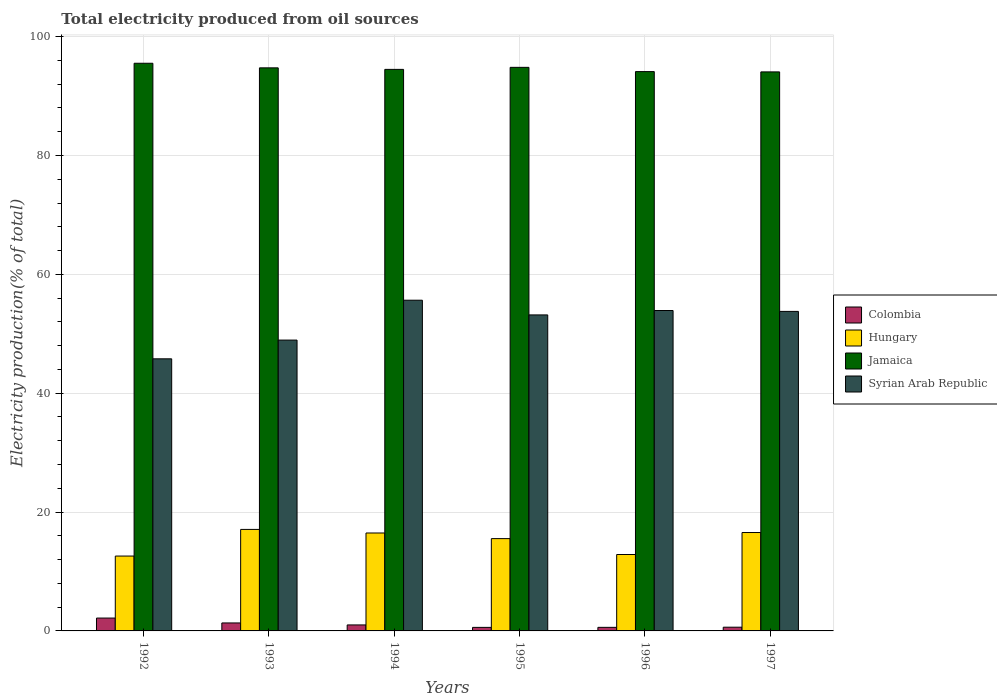How many different coloured bars are there?
Keep it short and to the point. 4. Are the number of bars on each tick of the X-axis equal?
Provide a short and direct response. Yes. How many bars are there on the 2nd tick from the left?
Provide a short and direct response. 4. What is the label of the 2nd group of bars from the left?
Make the answer very short. 1993. In how many cases, is the number of bars for a given year not equal to the number of legend labels?
Provide a succinct answer. 0. What is the total electricity produced in Hungary in 1997?
Your answer should be compact. 16.56. Across all years, what is the maximum total electricity produced in Hungary?
Keep it short and to the point. 17.08. Across all years, what is the minimum total electricity produced in Jamaica?
Your answer should be compact. 94.07. In which year was the total electricity produced in Syrian Arab Republic maximum?
Provide a short and direct response. 1994. What is the total total electricity produced in Syrian Arab Republic in the graph?
Offer a very short reply. 311.24. What is the difference between the total electricity produced in Hungary in 1994 and that in 1995?
Make the answer very short. 0.95. What is the difference between the total electricity produced in Syrian Arab Republic in 1996 and the total electricity produced in Jamaica in 1995?
Offer a terse response. -40.92. What is the average total electricity produced in Jamaica per year?
Ensure brevity in your answer.  94.63. In the year 1995, what is the difference between the total electricity produced in Jamaica and total electricity produced in Syrian Arab Republic?
Your answer should be very brief. 41.66. In how many years, is the total electricity produced in Hungary greater than 84 %?
Provide a short and direct response. 0. What is the ratio of the total electricity produced in Jamaica in 1992 to that in 1993?
Make the answer very short. 1.01. Is the total electricity produced in Syrian Arab Republic in 1996 less than that in 1997?
Give a very brief answer. No. Is the difference between the total electricity produced in Jamaica in 1994 and 1995 greater than the difference between the total electricity produced in Syrian Arab Republic in 1994 and 1995?
Provide a succinct answer. No. What is the difference between the highest and the second highest total electricity produced in Colombia?
Your answer should be compact. 0.82. What is the difference between the highest and the lowest total electricity produced in Syrian Arab Republic?
Your response must be concise. 9.86. Is the sum of the total electricity produced in Jamaica in 1995 and 1997 greater than the maximum total electricity produced in Colombia across all years?
Offer a terse response. Yes. What does the 2nd bar from the left in 1997 represents?
Provide a short and direct response. Hungary. What does the 2nd bar from the right in 1995 represents?
Offer a terse response. Jamaica. How many bars are there?
Make the answer very short. 24. Are all the bars in the graph horizontal?
Keep it short and to the point. No. How many years are there in the graph?
Keep it short and to the point. 6. Are the values on the major ticks of Y-axis written in scientific E-notation?
Ensure brevity in your answer.  No. Does the graph contain any zero values?
Give a very brief answer. No. How many legend labels are there?
Your answer should be very brief. 4. What is the title of the graph?
Ensure brevity in your answer.  Total electricity produced from oil sources. Does "East Asia (developing only)" appear as one of the legend labels in the graph?
Your response must be concise. No. What is the label or title of the X-axis?
Your answer should be compact. Years. What is the label or title of the Y-axis?
Give a very brief answer. Electricity production(% of total). What is the Electricity production(% of total) of Colombia in 1992?
Your response must be concise. 2.16. What is the Electricity production(% of total) of Hungary in 1992?
Ensure brevity in your answer.  12.6. What is the Electricity production(% of total) of Jamaica in 1992?
Provide a short and direct response. 95.52. What is the Electricity production(% of total) in Syrian Arab Republic in 1992?
Offer a terse response. 45.79. What is the Electricity production(% of total) of Colombia in 1993?
Make the answer very short. 1.34. What is the Electricity production(% of total) in Hungary in 1993?
Keep it short and to the point. 17.08. What is the Electricity production(% of total) in Jamaica in 1993?
Keep it short and to the point. 94.75. What is the Electricity production(% of total) of Syrian Arab Republic in 1993?
Offer a very short reply. 48.94. What is the Electricity production(% of total) of Colombia in 1994?
Offer a very short reply. 1.01. What is the Electricity production(% of total) of Hungary in 1994?
Make the answer very short. 16.48. What is the Electricity production(% of total) in Jamaica in 1994?
Keep it short and to the point. 94.49. What is the Electricity production(% of total) in Syrian Arab Republic in 1994?
Your answer should be very brief. 55.65. What is the Electricity production(% of total) of Colombia in 1995?
Your answer should be compact. 0.59. What is the Electricity production(% of total) in Hungary in 1995?
Keep it short and to the point. 15.53. What is the Electricity production(% of total) of Jamaica in 1995?
Keep it short and to the point. 94.84. What is the Electricity production(% of total) in Syrian Arab Republic in 1995?
Make the answer very short. 53.18. What is the Electricity production(% of total) in Colombia in 1996?
Ensure brevity in your answer.  0.6. What is the Electricity production(% of total) of Hungary in 1996?
Your response must be concise. 12.86. What is the Electricity production(% of total) in Jamaica in 1996?
Ensure brevity in your answer.  94.12. What is the Electricity production(% of total) in Syrian Arab Republic in 1996?
Your response must be concise. 53.92. What is the Electricity production(% of total) of Colombia in 1997?
Give a very brief answer. 0.63. What is the Electricity production(% of total) of Hungary in 1997?
Your answer should be compact. 16.56. What is the Electricity production(% of total) of Jamaica in 1997?
Your answer should be compact. 94.07. What is the Electricity production(% of total) of Syrian Arab Republic in 1997?
Your answer should be very brief. 53.77. Across all years, what is the maximum Electricity production(% of total) of Colombia?
Your answer should be compact. 2.16. Across all years, what is the maximum Electricity production(% of total) in Hungary?
Your answer should be very brief. 17.08. Across all years, what is the maximum Electricity production(% of total) of Jamaica?
Your answer should be very brief. 95.52. Across all years, what is the maximum Electricity production(% of total) in Syrian Arab Republic?
Give a very brief answer. 55.65. Across all years, what is the minimum Electricity production(% of total) of Colombia?
Your answer should be very brief. 0.59. Across all years, what is the minimum Electricity production(% of total) in Hungary?
Offer a terse response. 12.6. Across all years, what is the minimum Electricity production(% of total) of Jamaica?
Your answer should be very brief. 94.07. Across all years, what is the minimum Electricity production(% of total) in Syrian Arab Republic?
Give a very brief answer. 45.79. What is the total Electricity production(% of total) in Colombia in the graph?
Provide a short and direct response. 6.34. What is the total Electricity production(% of total) in Hungary in the graph?
Your answer should be compact. 91.11. What is the total Electricity production(% of total) in Jamaica in the graph?
Ensure brevity in your answer.  567.79. What is the total Electricity production(% of total) of Syrian Arab Republic in the graph?
Make the answer very short. 311.24. What is the difference between the Electricity production(% of total) in Colombia in 1992 and that in 1993?
Ensure brevity in your answer.  0.82. What is the difference between the Electricity production(% of total) in Hungary in 1992 and that in 1993?
Your answer should be compact. -4.48. What is the difference between the Electricity production(% of total) in Jamaica in 1992 and that in 1993?
Your answer should be compact. 0.77. What is the difference between the Electricity production(% of total) of Syrian Arab Republic in 1992 and that in 1993?
Provide a short and direct response. -3.15. What is the difference between the Electricity production(% of total) in Colombia in 1992 and that in 1994?
Provide a succinct answer. 1.15. What is the difference between the Electricity production(% of total) of Hungary in 1992 and that in 1994?
Keep it short and to the point. -3.88. What is the difference between the Electricity production(% of total) in Jamaica in 1992 and that in 1994?
Offer a very short reply. 1.03. What is the difference between the Electricity production(% of total) of Syrian Arab Republic in 1992 and that in 1994?
Ensure brevity in your answer.  -9.86. What is the difference between the Electricity production(% of total) in Colombia in 1992 and that in 1995?
Give a very brief answer. 1.57. What is the difference between the Electricity production(% of total) in Hungary in 1992 and that in 1995?
Your answer should be compact. -2.93. What is the difference between the Electricity production(% of total) in Jamaica in 1992 and that in 1995?
Make the answer very short. 0.69. What is the difference between the Electricity production(% of total) in Syrian Arab Republic in 1992 and that in 1995?
Keep it short and to the point. -7.39. What is the difference between the Electricity production(% of total) of Colombia in 1992 and that in 1996?
Ensure brevity in your answer.  1.56. What is the difference between the Electricity production(% of total) of Hungary in 1992 and that in 1996?
Provide a short and direct response. -0.26. What is the difference between the Electricity production(% of total) of Jamaica in 1992 and that in 1996?
Your response must be concise. 1.4. What is the difference between the Electricity production(% of total) in Syrian Arab Republic in 1992 and that in 1996?
Make the answer very short. -8.13. What is the difference between the Electricity production(% of total) of Colombia in 1992 and that in 1997?
Provide a succinct answer. 1.54. What is the difference between the Electricity production(% of total) in Hungary in 1992 and that in 1997?
Your answer should be compact. -3.96. What is the difference between the Electricity production(% of total) of Jamaica in 1992 and that in 1997?
Offer a very short reply. 1.46. What is the difference between the Electricity production(% of total) in Syrian Arab Republic in 1992 and that in 1997?
Give a very brief answer. -7.98. What is the difference between the Electricity production(% of total) in Colombia in 1993 and that in 1994?
Provide a short and direct response. 0.33. What is the difference between the Electricity production(% of total) of Hungary in 1993 and that in 1994?
Offer a very short reply. 0.6. What is the difference between the Electricity production(% of total) of Jamaica in 1993 and that in 1994?
Your response must be concise. 0.26. What is the difference between the Electricity production(% of total) of Syrian Arab Republic in 1993 and that in 1994?
Offer a very short reply. -6.71. What is the difference between the Electricity production(% of total) in Colombia in 1993 and that in 1995?
Ensure brevity in your answer.  0.75. What is the difference between the Electricity production(% of total) of Hungary in 1993 and that in 1995?
Your answer should be very brief. 1.55. What is the difference between the Electricity production(% of total) in Jamaica in 1993 and that in 1995?
Provide a succinct answer. -0.09. What is the difference between the Electricity production(% of total) in Syrian Arab Republic in 1993 and that in 1995?
Your answer should be compact. -4.24. What is the difference between the Electricity production(% of total) in Colombia in 1993 and that in 1996?
Provide a succinct answer. 0.74. What is the difference between the Electricity production(% of total) in Hungary in 1993 and that in 1996?
Make the answer very short. 4.22. What is the difference between the Electricity production(% of total) of Jamaica in 1993 and that in 1996?
Make the answer very short. 0.63. What is the difference between the Electricity production(% of total) of Syrian Arab Republic in 1993 and that in 1996?
Make the answer very short. -4.98. What is the difference between the Electricity production(% of total) of Colombia in 1993 and that in 1997?
Offer a terse response. 0.72. What is the difference between the Electricity production(% of total) of Hungary in 1993 and that in 1997?
Provide a succinct answer. 0.52. What is the difference between the Electricity production(% of total) of Jamaica in 1993 and that in 1997?
Provide a short and direct response. 0.68. What is the difference between the Electricity production(% of total) in Syrian Arab Republic in 1993 and that in 1997?
Offer a terse response. -4.83. What is the difference between the Electricity production(% of total) in Colombia in 1994 and that in 1995?
Make the answer very short. 0.41. What is the difference between the Electricity production(% of total) of Hungary in 1994 and that in 1995?
Give a very brief answer. 0.95. What is the difference between the Electricity production(% of total) of Jamaica in 1994 and that in 1995?
Your response must be concise. -0.34. What is the difference between the Electricity production(% of total) of Syrian Arab Republic in 1994 and that in 1995?
Offer a terse response. 2.47. What is the difference between the Electricity production(% of total) of Colombia in 1994 and that in 1996?
Your answer should be very brief. 0.41. What is the difference between the Electricity production(% of total) of Hungary in 1994 and that in 1996?
Keep it short and to the point. 3.62. What is the difference between the Electricity production(% of total) in Jamaica in 1994 and that in 1996?
Your answer should be compact. 0.37. What is the difference between the Electricity production(% of total) in Syrian Arab Republic in 1994 and that in 1996?
Your answer should be very brief. 1.73. What is the difference between the Electricity production(% of total) of Colombia in 1994 and that in 1997?
Give a very brief answer. 0.38. What is the difference between the Electricity production(% of total) of Hungary in 1994 and that in 1997?
Offer a very short reply. -0.08. What is the difference between the Electricity production(% of total) of Jamaica in 1994 and that in 1997?
Your response must be concise. 0.42. What is the difference between the Electricity production(% of total) in Syrian Arab Republic in 1994 and that in 1997?
Offer a very short reply. 1.88. What is the difference between the Electricity production(% of total) of Colombia in 1995 and that in 1996?
Provide a succinct answer. -0.01. What is the difference between the Electricity production(% of total) of Hungary in 1995 and that in 1996?
Give a very brief answer. 2.67. What is the difference between the Electricity production(% of total) in Jamaica in 1995 and that in 1996?
Offer a terse response. 0.72. What is the difference between the Electricity production(% of total) in Syrian Arab Republic in 1995 and that in 1996?
Offer a terse response. -0.74. What is the difference between the Electricity production(% of total) in Colombia in 1995 and that in 1997?
Offer a terse response. -0.03. What is the difference between the Electricity production(% of total) of Hungary in 1995 and that in 1997?
Your answer should be very brief. -1.02. What is the difference between the Electricity production(% of total) of Jamaica in 1995 and that in 1997?
Your answer should be very brief. 0.77. What is the difference between the Electricity production(% of total) in Syrian Arab Republic in 1995 and that in 1997?
Your answer should be very brief. -0.59. What is the difference between the Electricity production(% of total) of Colombia in 1996 and that in 1997?
Offer a very short reply. -0.03. What is the difference between the Electricity production(% of total) in Hungary in 1996 and that in 1997?
Give a very brief answer. -3.7. What is the difference between the Electricity production(% of total) in Jamaica in 1996 and that in 1997?
Make the answer very short. 0.05. What is the difference between the Electricity production(% of total) of Syrian Arab Republic in 1996 and that in 1997?
Give a very brief answer. 0.15. What is the difference between the Electricity production(% of total) of Colombia in 1992 and the Electricity production(% of total) of Hungary in 1993?
Your answer should be very brief. -14.92. What is the difference between the Electricity production(% of total) in Colombia in 1992 and the Electricity production(% of total) in Jamaica in 1993?
Keep it short and to the point. -92.59. What is the difference between the Electricity production(% of total) in Colombia in 1992 and the Electricity production(% of total) in Syrian Arab Republic in 1993?
Give a very brief answer. -46.78. What is the difference between the Electricity production(% of total) in Hungary in 1992 and the Electricity production(% of total) in Jamaica in 1993?
Give a very brief answer. -82.15. What is the difference between the Electricity production(% of total) in Hungary in 1992 and the Electricity production(% of total) in Syrian Arab Republic in 1993?
Offer a terse response. -36.34. What is the difference between the Electricity production(% of total) in Jamaica in 1992 and the Electricity production(% of total) in Syrian Arab Republic in 1993?
Your response must be concise. 46.58. What is the difference between the Electricity production(% of total) in Colombia in 1992 and the Electricity production(% of total) in Hungary in 1994?
Keep it short and to the point. -14.31. What is the difference between the Electricity production(% of total) in Colombia in 1992 and the Electricity production(% of total) in Jamaica in 1994?
Make the answer very short. -92.33. What is the difference between the Electricity production(% of total) in Colombia in 1992 and the Electricity production(% of total) in Syrian Arab Republic in 1994?
Provide a short and direct response. -53.49. What is the difference between the Electricity production(% of total) of Hungary in 1992 and the Electricity production(% of total) of Jamaica in 1994?
Offer a very short reply. -81.89. What is the difference between the Electricity production(% of total) in Hungary in 1992 and the Electricity production(% of total) in Syrian Arab Republic in 1994?
Your response must be concise. -43.05. What is the difference between the Electricity production(% of total) of Jamaica in 1992 and the Electricity production(% of total) of Syrian Arab Republic in 1994?
Provide a succinct answer. 39.87. What is the difference between the Electricity production(% of total) of Colombia in 1992 and the Electricity production(% of total) of Hungary in 1995?
Your answer should be compact. -13.37. What is the difference between the Electricity production(% of total) of Colombia in 1992 and the Electricity production(% of total) of Jamaica in 1995?
Provide a short and direct response. -92.67. What is the difference between the Electricity production(% of total) in Colombia in 1992 and the Electricity production(% of total) in Syrian Arab Republic in 1995?
Offer a very short reply. -51.01. What is the difference between the Electricity production(% of total) in Hungary in 1992 and the Electricity production(% of total) in Jamaica in 1995?
Provide a short and direct response. -82.24. What is the difference between the Electricity production(% of total) in Hungary in 1992 and the Electricity production(% of total) in Syrian Arab Republic in 1995?
Provide a short and direct response. -40.58. What is the difference between the Electricity production(% of total) in Jamaica in 1992 and the Electricity production(% of total) in Syrian Arab Republic in 1995?
Provide a succinct answer. 42.35. What is the difference between the Electricity production(% of total) in Colombia in 1992 and the Electricity production(% of total) in Hungary in 1996?
Your answer should be very brief. -10.69. What is the difference between the Electricity production(% of total) in Colombia in 1992 and the Electricity production(% of total) in Jamaica in 1996?
Provide a short and direct response. -91.96. What is the difference between the Electricity production(% of total) of Colombia in 1992 and the Electricity production(% of total) of Syrian Arab Republic in 1996?
Make the answer very short. -51.75. What is the difference between the Electricity production(% of total) in Hungary in 1992 and the Electricity production(% of total) in Jamaica in 1996?
Make the answer very short. -81.52. What is the difference between the Electricity production(% of total) in Hungary in 1992 and the Electricity production(% of total) in Syrian Arab Republic in 1996?
Your answer should be compact. -41.32. What is the difference between the Electricity production(% of total) in Jamaica in 1992 and the Electricity production(% of total) in Syrian Arab Republic in 1996?
Your response must be concise. 41.61. What is the difference between the Electricity production(% of total) of Colombia in 1992 and the Electricity production(% of total) of Hungary in 1997?
Offer a very short reply. -14.39. What is the difference between the Electricity production(% of total) in Colombia in 1992 and the Electricity production(% of total) in Jamaica in 1997?
Offer a terse response. -91.9. What is the difference between the Electricity production(% of total) in Colombia in 1992 and the Electricity production(% of total) in Syrian Arab Republic in 1997?
Your answer should be compact. -51.6. What is the difference between the Electricity production(% of total) of Hungary in 1992 and the Electricity production(% of total) of Jamaica in 1997?
Your answer should be very brief. -81.47. What is the difference between the Electricity production(% of total) in Hungary in 1992 and the Electricity production(% of total) in Syrian Arab Republic in 1997?
Give a very brief answer. -41.17. What is the difference between the Electricity production(% of total) of Jamaica in 1992 and the Electricity production(% of total) of Syrian Arab Republic in 1997?
Provide a succinct answer. 41.76. What is the difference between the Electricity production(% of total) in Colombia in 1993 and the Electricity production(% of total) in Hungary in 1994?
Make the answer very short. -15.14. What is the difference between the Electricity production(% of total) in Colombia in 1993 and the Electricity production(% of total) in Jamaica in 1994?
Your response must be concise. -93.15. What is the difference between the Electricity production(% of total) in Colombia in 1993 and the Electricity production(% of total) in Syrian Arab Republic in 1994?
Provide a succinct answer. -54.31. What is the difference between the Electricity production(% of total) of Hungary in 1993 and the Electricity production(% of total) of Jamaica in 1994?
Your response must be concise. -77.41. What is the difference between the Electricity production(% of total) in Hungary in 1993 and the Electricity production(% of total) in Syrian Arab Republic in 1994?
Your response must be concise. -38.57. What is the difference between the Electricity production(% of total) in Jamaica in 1993 and the Electricity production(% of total) in Syrian Arab Republic in 1994?
Offer a terse response. 39.1. What is the difference between the Electricity production(% of total) of Colombia in 1993 and the Electricity production(% of total) of Hungary in 1995?
Offer a very short reply. -14.19. What is the difference between the Electricity production(% of total) of Colombia in 1993 and the Electricity production(% of total) of Jamaica in 1995?
Ensure brevity in your answer.  -93.49. What is the difference between the Electricity production(% of total) in Colombia in 1993 and the Electricity production(% of total) in Syrian Arab Republic in 1995?
Provide a short and direct response. -51.83. What is the difference between the Electricity production(% of total) in Hungary in 1993 and the Electricity production(% of total) in Jamaica in 1995?
Provide a short and direct response. -77.76. What is the difference between the Electricity production(% of total) of Hungary in 1993 and the Electricity production(% of total) of Syrian Arab Republic in 1995?
Keep it short and to the point. -36.1. What is the difference between the Electricity production(% of total) of Jamaica in 1993 and the Electricity production(% of total) of Syrian Arab Republic in 1995?
Provide a short and direct response. 41.57. What is the difference between the Electricity production(% of total) of Colombia in 1993 and the Electricity production(% of total) of Hungary in 1996?
Provide a short and direct response. -11.52. What is the difference between the Electricity production(% of total) of Colombia in 1993 and the Electricity production(% of total) of Jamaica in 1996?
Offer a very short reply. -92.78. What is the difference between the Electricity production(% of total) of Colombia in 1993 and the Electricity production(% of total) of Syrian Arab Republic in 1996?
Your answer should be very brief. -52.57. What is the difference between the Electricity production(% of total) in Hungary in 1993 and the Electricity production(% of total) in Jamaica in 1996?
Your response must be concise. -77.04. What is the difference between the Electricity production(% of total) of Hungary in 1993 and the Electricity production(% of total) of Syrian Arab Republic in 1996?
Provide a short and direct response. -36.84. What is the difference between the Electricity production(% of total) of Jamaica in 1993 and the Electricity production(% of total) of Syrian Arab Republic in 1996?
Make the answer very short. 40.83. What is the difference between the Electricity production(% of total) of Colombia in 1993 and the Electricity production(% of total) of Hungary in 1997?
Ensure brevity in your answer.  -15.21. What is the difference between the Electricity production(% of total) of Colombia in 1993 and the Electricity production(% of total) of Jamaica in 1997?
Keep it short and to the point. -92.73. What is the difference between the Electricity production(% of total) in Colombia in 1993 and the Electricity production(% of total) in Syrian Arab Republic in 1997?
Give a very brief answer. -52.42. What is the difference between the Electricity production(% of total) in Hungary in 1993 and the Electricity production(% of total) in Jamaica in 1997?
Give a very brief answer. -76.99. What is the difference between the Electricity production(% of total) in Hungary in 1993 and the Electricity production(% of total) in Syrian Arab Republic in 1997?
Offer a very short reply. -36.69. What is the difference between the Electricity production(% of total) of Jamaica in 1993 and the Electricity production(% of total) of Syrian Arab Republic in 1997?
Provide a succinct answer. 40.98. What is the difference between the Electricity production(% of total) in Colombia in 1994 and the Electricity production(% of total) in Hungary in 1995?
Ensure brevity in your answer.  -14.52. What is the difference between the Electricity production(% of total) in Colombia in 1994 and the Electricity production(% of total) in Jamaica in 1995?
Keep it short and to the point. -93.83. What is the difference between the Electricity production(% of total) of Colombia in 1994 and the Electricity production(% of total) of Syrian Arab Republic in 1995?
Provide a short and direct response. -52.17. What is the difference between the Electricity production(% of total) in Hungary in 1994 and the Electricity production(% of total) in Jamaica in 1995?
Make the answer very short. -78.36. What is the difference between the Electricity production(% of total) in Hungary in 1994 and the Electricity production(% of total) in Syrian Arab Republic in 1995?
Your response must be concise. -36.7. What is the difference between the Electricity production(% of total) of Jamaica in 1994 and the Electricity production(% of total) of Syrian Arab Republic in 1995?
Make the answer very short. 41.32. What is the difference between the Electricity production(% of total) of Colombia in 1994 and the Electricity production(% of total) of Hungary in 1996?
Provide a succinct answer. -11.85. What is the difference between the Electricity production(% of total) of Colombia in 1994 and the Electricity production(% of total) of Jamaica in 1996?
Give a very brief answer. -93.11. What is the difference between the Electricity production(% of total) in Colombia in 1994 and the Electricity production(% of total) in Syrian Arab Republic in 1996?
Keep it short and to the point. -52.91. What is the difference between the Electricity production(% of total) in Hungary in 1994 and the Electricity production(% of total) in Jamaica in 1996?
Your response must be concise. -77.64. What is the difference between the Electricity production(% of total) in Hungary in 1994 and the Electricity production(% of total) in Syrian Arab Republic in 1996?
Provide a short and direct response. -37.44. What is the difference between the Electricity production(% of total) in Jamaica in 1994 and the Electricity production(% of total) in Syrian Arab Republic in 1996?
Give a very brief answer. 40.57. What is the difference between the Electricity production(% of total) in Colombia in 1994 and the Electricity production(% of total) in Hungary in 1997?
Ensure brevity in your answer.  -15.55. What is the difference between the Electricity production(% of total) in Colombia in 1994 and the Electricity production(% of total) in Jamaica in 1997?
Your response must be concise. -93.06. What is the difference between the Electricity production(% of total) in Colombia in 1994 and the Electricity production(% of total) in Syrian Arab Republic in 1997?
Provide a short and direct response. -52.76. What is the difference between the Electricity production(% of total) of Hungary in 1994 and the Electricity production(% of total) of Jamaica in 1997?
Your response must be concise. -77.59. What is the difference between the Electricity production(% of total) of Hungary in 1994 and the Electricity production(% of total) of Syrian Arab Republic in 1997?
Ensure brevity in your answer.  -37.29. What is the difference between the Electricity production(% of total) in Jamaica in 1994 and the Electricity production(% of total) in Syrian Arab Republic in 1997?
Keep it short and to the point. 40.73. What is the difference between the Electricity production(% of total) of Colombia in 1995 and the Electricity production(% of total) of Hungary in 1996?
Make the answer very short. -12.26. What is the difference between the Electricity production(% of total) of Colombia in 1995 and the Electricity production(% of total) of Jamaica in 1996?
Keep it short and to the point. -93.53. What is the difference between the Electricity production(% of total) of Colombia in 1995 and the Electricity production(% of total) of Syrian Arab Republic in 1996?
Your answer should be compact. -53.32. What is the difference between the Electricity production(% of total) of Hungary in 1995 and the Electricity production(% of total) of Jamaica in 1996?
Your response must be concise. -78.59. What is the difference between the Electricity production(% of total) in Hungary in 1995 and the Electricity production(% of total) in Syrian Arab Republic in 1996?
Give a very brief answer. -38.38. What is the difference between the Electricity production(% of total) of Jamaica in 1995 and the Electricity production(% of total) of Syrian Arab Republic in 1996?
Your answer should be compact. 40.92. What is the difference between the Electricity production(% of total) in Colombia in 1995 and the Electricity production(% of total) in Hungary in 1997?
Keep it short and to the point. -15.96. What is the difference between the Electricity production(% of total) of Colombia in 1995 and the Electricity production(% of total) of Jamaica in 1997?
Make the answer very short. -93.47. What is the difference between the Electricity production(% of total) in Colombia in 1995 and the Electricity production(% of total) in Syrian Arab Republic in 1997?
Ensure brevity in your answer.  -53.17. What is the difference between the Electricity production(% of total) of Hungary in 1995 and the Electricity production(% of total) of Jamaica in 1997?
Offer a terse response. -78.54. What is the difference between the Electricity production(% of total) in Hungary in 1995 and the Electricity production(% of total) in Syrian Arab Republic in 1997?
Ensure brevity in your answer.  -38.23. What is the difference between the Electricity production(% of total) in Jamaica in 1995 and the Electricity production(% of total) in Syrian Arab Republic in 1997?
Provide a succinct answer. 41.07. What is the difference between the Electricity production(% of total) of Colombia in 1996 and the Electricity production(% of total) of Hungary in 1997?
Your response must be concise. -15.96. What is the difference between the Electricity production(% of total) of Colombia in 1996 and the Electricity production(% of total) of Jamaica in 1997?
Provide a short and direct response. -93.47. What is the difference between the Electricity production(% of total) of Colombia in 1996 and the Electricity production(% of total) of Syrian Arab Republic in 1997?
Provide a succinct answer. -53.16. What is the difference between the Electricity production(% of total) of Hungary in 1996 and the Electricity production(% of total) of Jamaica in 1997?
Keep it short and to the point. -81.21. What is the difference between the Electricity production(% of total) in Hungary in 1996 and the Electricity production(% of total) in Syrian Arab Republic in 1997?
Make the answer very short. -40.91. What is the difference between the Electricity production(% of total) in Jamaica in 1996 and the Electricity production(% of total) in Syrian Arab Republic in 1997?
Make the answer very short. 40.35. What is the average Electricity production(% of total) of Colombia per year?
Provide a short and direct response. 1.06. What is the average Electricity production(% of total) of Hungary per year?
Ensure brevity in your answer.  15.18. What is the average Electricity production(% of total) in Jamaica per year?
Your answer should be very brief. 94.63. What is the average Electricity production(% of total) of Syrian Arab Republic per year?
Keep it short and to the point. 51.87. In the year 1992, what is the difference between the Electricity production(% of total) in Colombia and Electricity production(% of total) in Hungary?
Ensure brevity in your answer.  -10.43. In the year 1992, what is the difference between the Electricity production(% of total) in Colombia and Electricity production(% of total) in Jamaica?
Offer a terse response. -93.36. In the year 1992, what is the difference between the Electricity production(% of total) in Colombia and Electricity production(% of total) in Syrian Arab Republic?
Make the answer very short. -43.62. In the year 1992, what is the difference between the Electricity production(% of total) of Hungary and Electricity production(% of total) of Jamaica?
Your answer should be very brief. -82.92. In the year 1992, what is the difference between the Electricity production(% of total) of Hungary and Electricity production(% of total) of Syrian Arab Republic?
Offer a terse response. -33.19. In the year 1992, what is the difference between the Electricity production(% of total) in Jamaica and Electricity production(% of total) in Syrian Arab Republic?
Give a very brief answer. 49.73. In the year 1993, what is the difference between the Electricity production(% of total) of Colombia and Electricity production(% of total) of Hungary?
Offer a terse response. -15.74. In the year 1993, what is the difference between the Electricity production(% of total) in Colombia and Electricity production(% of total) in Jamaica?
Offer a very short reply. -93.41. In the year 1993, what is the difference between the Electricity production(% of total) of Colombia and Electricity production(% of total) of Syrian Arab Republic?
Your answer should be compact. -47.6. In the year 1993, what is the difference between the Electricity production(% of total) of Hungary and Electricity production(% of total) of Jamaica?
Your response must be concise. -77.67. In the year 1993, what is the difference between the Electricity production(% of total) in Hungary and Electricity production(% of total) in Syrian Arab Republic?
Offer a very short reply. -31.86. In the year 1993, what is the difference between the Electricity production(% of total) in Jamaica and Electricity production(% of total) in Syrian Arab Republic?
Offer a terse response. 45.81. In the year 1994, what is the difference between the Electricity production(% of total) in Colombia and Electricity production(% of total) in Hungary?
Offer a terse response. -15.47. In the year 1994, what is the difference between the Electricity production(% of total) of Colombia and Electricity production(% of total) of Jamaica?
Offer a very short reply. -93.48. In the year 1994, what is the difference between the Electricity production(% of total) in Colombia and Electricity production(% of total) in Syrian Arab Republic?
Keep it short and to the point. -54.64. In the year 1994, what is the difference between the Electricity production(% of total) in Hungary and Electricity production(% of total) in Jamaica?
Offer a terse response. -78.01. In the year 1994, what is the difference between the Electricity production(% of total) of Hungary and Electricity production(% of total) of Syrian Arab Republic?
Your answer should be compact. -39.17. In the year 1994, what is the difference between the Electricity production(% of total) of Jamaica and Electricity production(% of total) of Syrian Arab Republic?
Provide a short and direct response. 38.84. In the year 1995, what is the difference between the Electricity production(% of total) of Colombia and Electricity production(% of total) of Hungary?
Your answer should be compact. -14.94. In the year 1995, what is the difference between the Electricity production(% of total) of Colombia and Electricity production(% of total) of Jamaica?
Make the answer very short. -94.24. In the year 1995, what is the difference between the Electricity production(% of total) in Colombia and Electricity production(% of total) in Syrian Arab Republic?
Give a very brief answer. -52.58. In the year 1995, what is the difference between the Electricity production(% of total) in Hungary and Electricity production(% of total) in Jamaica?
Offer a very short reply. -79.3. In the year 1995, what is the difference between the Electricity production(% of total) in Hungary and Electricity production(% of total) in Syrian Arab Republic?
Your answer should be very brief. -37.64. In the year 1995, what is the difference between the Electricity production(% of total) in Jamaica and Electricity production(% of total) in Syrian Arab Republic?
Ensure brevity in your answer.  41.66. In the year 1996, what is the difference between the Electricity production(% of total) of Colombia and Electricity production(% of total) of Hungary?
Make the answer very short. -12.26. In the year 1996, what is the difference between the Electricity production(% of total) of Colombia and Electricity production(% of total) of Jamaica?
Provide a short and direct response. -93.52. In the year 1996, what is the difference between the Electricity production(% of total) in Colombia and Electricity production(% of total) in Syrian Arab Republic?
Your answer should be very brief. -53.32. In the year 1996, what is the difference between the Electricity production(% of total) of Hungary and Electricity production(% of total) of Jamaica?
Offer a terse response. -81.26. In the year 1996, what is the difference between the Electricity production(% of total) of Hungary and Electricity production(% of total) of Syrian Arab Republic?
Offer a very short reply. -41.06. In the year 1996, what is the difference between the Electricity production(% of total) in Jamaica and Electricity production(% of total) in Syrian Arab Republic?
Your answer should be compact. 40.2. In the year 1997, what is the difference between the Electricity production(% of total) of Colombia and Electricity production(% of total) of Hungary?
Your response must be concise. -15.93. In the year 1997, what is the difference between the Electricity production(% of total) in Colombia and Electricity production(% of total) in Jamaica?
Your response must be concise. -93.44. In the year 1997, what is the difference between the Electricity production(% of total) of Colombia and Electricity production(% of total) of Syrian Arab Republic?
Make the answer very short. -53.14. In the year 1997, what is the difference between the Electricity production(% of total) of Hungary and Electricity production(% of total) of Jamaica?
Make the answer very short. -77.51. In the year 1997, what is the difference between the Electricity production(% of total) of Hungary and Electricity production(% of total) of Syrian Arab Republic?
Offer a very short reply. -37.21. In the year 1997, what is the difference between the Electricity production(% of total) of Jamaica and Electricity production(% of total) of Syrian Arab Republic?
Ensure brevity in your answer.  40.3. What is the ratio of the Electricity production(% of total) in Colombia in 1992 to that in 1993?
Make the answer very short. 1.61. What is the ratio of the Electricity production(% of total) in Hungary in 1992 to that in 1993?
Offer a terse response. 0.74. What is the ratio of the Electricity production(% of total) of Jamaica in 1992 to that in 1993?
Give a very brief answer. 1.01. What is the ratio of the Electricity production(% of total) in Syrian Arab Republic in 1992 to that in 1993?
Give a very brief answer. 0.94. What is the ratio of the Electricity production(% of total) in Colombia in 1992 to that in 1994?
Your answer should be compact. 2.14. What is the ratio of the Electricity production(% of total) of Hungary in 1992 to that in 1994?
Your response must be concise. 0.76. What is the ratio of the Electricity production(% of total) of Jamaica in 1992 to that in 1994?
Ensure brevity in your answer.  1.01. What is the ratio of the Electricity production(% of total) in Syrian Arab Republic in 1992 to that in 1994?
Provide a short and direct response. 0.82. What is the ratio of the Electricity production(% of total) in Colombia in 1992 to that in 1995?
Ensure brevity in your answer.  3.64. What is the ratio of the Electricity production(% of total) in Hungary in 1992 to that in 1995?
Provide a short and direct response. 0.81. What is the ratio of the Electricity production(% of total) of Jamaica in 1992 to that in 1995?
Offer a very short reply. 1.01. What is the ratio of the Electricity production(% of total) of Syrian Arab Republic in 1992 to that in 1995?
Your response must be concise. 0.86. What is the ratio of the Electricity production(% of total) in Colombia in 1992 to that in 1996?
Your answer should be compact. 3.6. What is the ratio of the Electricity production(% of total) of Hungary in 1992 to that in 1996?
Offer a terse response. 0.98. What is the ratio of the Electricity production(% of total) of Jamaica in 1992 to that in 1996?
Your answer should be compact. 1.01. What is the ratio of the Electricity production(% of total) in Syrian Arab Republic in 1992 to that in 1996?
Provide a succinct answer. 0.85. What is the ratio of the Electricity production(% of total) in Colombia in 1992 to that in 1997?
Make the answer very short. 3.45. What is the ratio of the Electricity production(% of total) in Hungary in 1992 to that in 1997?
Offer a very short reply. 0.76. What is the ratio of the Electricity production(% of total) in Jamaica in 1992 to that in 1997?
Provide a short and direct response. 1.02. What is the ratio of the Electricity production(% of total) of Syrian Arab Republic in 1992 to that in 1997?
Keep it short and to the point. 0.85. What is the ratio of the Electricity production(% of total) in Colombia in 1993 to that in 1994?
Give a very brief answer. 1.33. What is the ratio of the Electricity production(% of total) of Hungary in 1993 to that in 1994?
Your response must be concise. 1.04. What is the ratio of the Electricity production(% of total) in Jamaica in 1993 to that in 1994?
Provide a short and direct response. 1. What is the ratio of the Electricity production(% of total) in Syrian Arab Republic in 1993 to that in 1994?
Offer a terse response. 0.88. What is the ratio of the Electricity production(% of total) of Colombia in 1993 to that in 1995?
Your answer should be very brief. 2.26. What is the ratio of the Electricity production(% of total) of Hungary in 1993 to that in 1995?
Provide a short and direct response. 1.1. What is the ratio of the Electricity production(% of total) of Jamaica in 1993 to that in 1995?
Give a very brief answer. 1. What is the ratio of the Electricity production(% of total) in Syrian Arab Republic in 1993 to that in 1995?
Your answer should be very brief. 0.92. What is the ratio of the Electricity production(% of total) in Colombia in 1993 to that in 1996?
Provide a succinct answer. 2.23. What is the ratio of the Electricity production(% of total) in Hungary in 1993 to that in 1996?
Offer a terse response. 1.33. What is the ratio of the Electricity production(% of total) in Jamaica in 1993 to that in 1996?
Provide a short and direct response. 1.01. What is the ratio of the Electricity production(% of total) of Syrian Arab Republic in 1993 to that in 1996?
Your answer should be compact. 0.91. What is the ratio of the Electricity production(% of total) of Colombia in 1993 to that in 1997?
Make the answer very short. 2.14. What is the ratio of the Electricity production(% of total) of Hungary in 1993 to that in 1997?
Offer a very short reply. 1.03. What is the ratio of the Electricity production(% of total) in Syrian Arab Republic in 1993 to that in 1997?
Your response must be concise. 0.91. What is the ratio of the Electricity production(% of total) in Colombia in 1994 to that in 1995?
Your answer should be compact. 1.7. What is the ratio of the Electricity production(% of total) of Hungary in 1994 to that in 1995?
Keep it short and to the point. 1.06. What is the ratio of the Electricity production(% of total) of Syrian Arab Republic in 1994 to that in 1995?
Your answer should be compact. 1.05. What is the ratio of the Electricity production(% of total) of Colombia in 1994 to that in 1996?
Your answer should be compact. 1.68. What is the ratio of the Electricity production(% of total) in Hungary in 1994 to that in 1996?
Keep it short and to the point. 1.28. What is the ratio of the Electricity production(% of total) of Jamaica in 1994 to that in 1996?
Your answer should be compact. 1. What is the ratio of the Electricity production(% of total) in Syrian Arab Republic in 1994 to that in 1996?
Your answer should be very brief. 1.03. What is the ratio of the Electricity production(% of total) in Colombia in 1994 to that in 1997?
Ensure brevity in your answer.  1.61. What is the ratio of the Electricity production(% of total) in Hungary in 1994 to that in 1997?
Your answer should be compact. 1. What is the ratio of the Electricity production(% of total) of Jamaica in 1994 to that in 1997?
Offer a terse response. 1. What is the ratio of the Electricity production(% of total) in Syrian Arab Republic in 1994 to that in 1997?
Provide a succinct answer. 1.03. What is the ratio of the Electricity production(% of total) of Colombia in 1995 to that in 1996?
Make the answer very short. 0.99. What is the ratio of the Electricity production(% of total) in Hungary in 1995 to that in 1996?
Your answer should be compact. 1.21. What is the ratio of the Electricity production(% of total) in Jamaica in 1995 to that in 1996?
Your answer should be compact. 1.01. What is the ratio of the Electricity production(% of total) in Syrian Arab Republic in 1995 to that in 1996?
Give a very brief answer. 0.99. What is the ratio of the Electricity production(% of total) in Colombia in 1995 to that in 1997?
Provide a succinct answer. 0.95. What is the ratio of the Electricity production(% of total) in Hungary in 1995 to that in 1997?
Offer a terse response. 0.94. What is the ratio of the Electricity production(% of total) in Jamaica in 1995 to that in 1997?
Give a very brief answer. 1.01. What is the ratio of the Electricity production(% of total) of Syrian Arab Republic in 1995 to that in 1997?
Ensure brevity in your answer.  0.99. What is the ratio of the Electricity production(% of total) in Colombia in 1996 to that in 1997?
Make the answer very short. 0.96. What is the ratio of the Electricity production(% of total) of Hungary in 1996 to that in 1997?
Ensure brevity in your answer.  0.78. What is the ratio of the Electricity production(% of total) of Jamaica in 1996 to that in 1997?
Ensure brevity in your answer.  1. What is the difference between the highest and the second highest Electricity production(% of total) in Colombia?
Make the answer very short. 0.82. What is the difference between the highest and the second highest Electricity production(% of total) of Hungary?
Offer a very short reply. 0.52. What is the difference between the highest and the second highest Electricity production(% of total) of Jamaica?
Your response must be concise. 0.69. What is the difference between the highest and the second highest Electricity production(% of total) of Syrian Arab Republic?
Offer a very short reply. 1.73. What is the difference between the highest and the lowest Electricity production(% of total) of Colombia?
Provide a succinct answer. 1.57. What is the difference between the highest and the lowest Electricity production(% of total) in Hungary?
Provide a succinct answer. 4.48. What is the difference between the highest and the lowest Electricity production(% of total) of Jamaica?
Provide a short and direct response. 1.46. What is the difference between the highest and the lowest Electricity production(% of total) of Syrian Arab Republic?
Your answer should be compact. 9.86. 